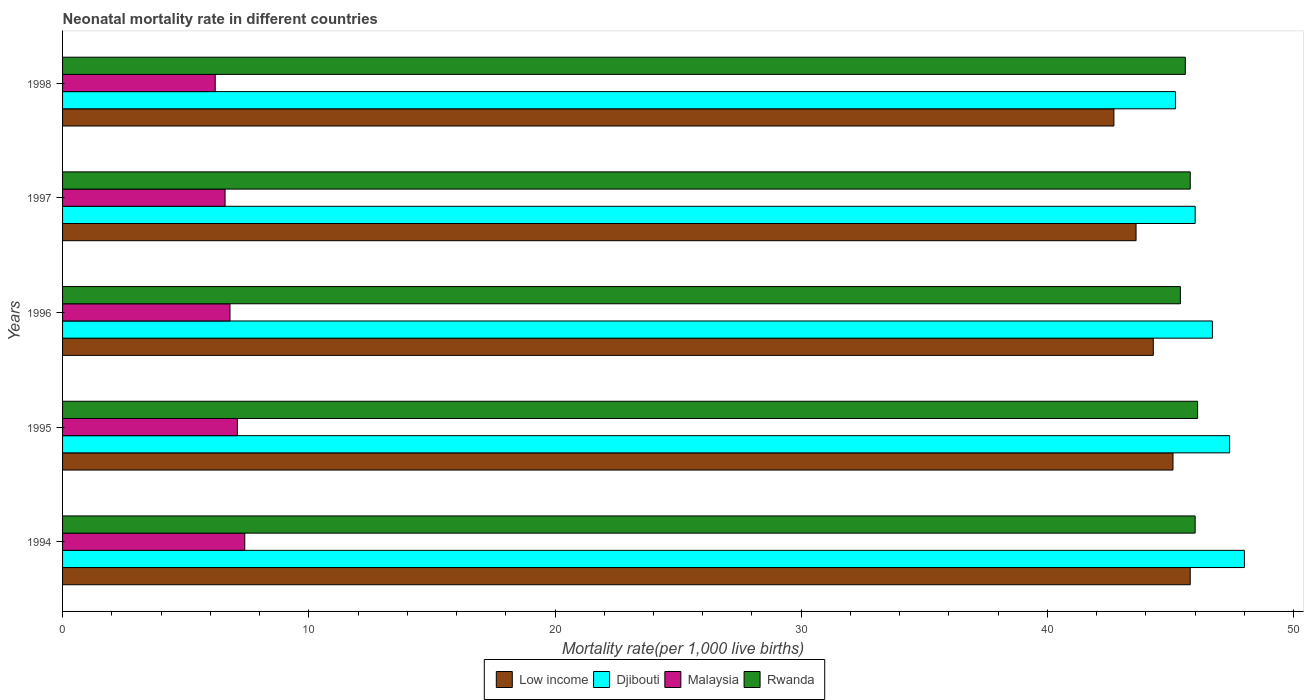Are the number of bars per tick equal to the number of legend labels?
Your answer should be very brief. Yes. Are the number of bars on each tick of the Y-axis equal?
Provide a succinct answer. Yes. How many bars are there on the 1st tick from the top?
Make the answer very short. 4. In how many cases, is the number of bars for a given year not equal to the number of legend labels?
Your answer should be compact. 0. What is the neonatal mortality rate in Djibouti in 1995?
Make the answer very short. 47.4. Across all years, what is the minimum neonatal mortality rate in Djibouti?
Ensure brevity in your answer.  45.2. In which year was the neonatal mortality rate in Low income maximum?
Offer a terse response. 1994. What is the total neonatal mortality rate in Djibouti in the graph?
Offer a terse response. 233.3. What is the difference between the neonatal mortality rate in Djibouti in 1994 and that in 1997?
Your answer should be very brief. 2. What is the difference between the neonatal mortality rate in Djibouti in 1996 and the neonatal mortality rate in Malaysia in 1998?
Your response must be concise. 40.5. What is the average neonatal mortality rate in Djibouti per year?
Give a very brief answer. 46.66. In the year 1997, what is the difference between the neonatal mortality rate in Low income and neonatal mortality rate in Rwanda?
Your answer should be very brief. -2.2. In how many years, is the neonatal mortality rate in Rwanda greater than 18 ?
Ensure brevity in your answer.  5. What is the ratio of the neonatal mortality rate in Low income in 1995 to that in 1996?
Give a very brief answer. 1.02. Is the neonatal mortality rate in Malaysia in 1995 less than that in 1997?
Keep it short and to the point. No. What is the difference between the highest and the second highest neonatal mortality rate in Djibouti?
Provide a short and direct response. 0.6. What is the difference between the highest and the lowest neonatal mortality rate in Malaysia?
Your answer should be compact. 1.2. What does the 2nd bar from the top in 1996 represents?
Provide a short and direct response. Malaysia. What does the 3rd bar from the bottom in 1998 represents?
Offer a very short reply. Malaysia. How many years are there in the graph?
Give a very brief answer. 5. What is the difference between two consecutive major ticks on the X-axis?
Your response must be concise. 10. Are the values on the major ticks of X-axis written in scientific E-notation?
Ensure brevity in your answer.  No. How many legend labels are there?
Offer a terse response. 4. How are the legend labels stacked?
Your answer should be very brief. Horizontal. What is the title of the graph?
Your answer should be very brief. Neonatal mortality rate in different countries. Does "Ireland" appear as one of the legend labels in the graph?
Provide a succinct answer. No. What is the label or title of the X-axis?
Offer a terse response. Mortality rate(per 1,0 live births). What is the label or title of the Y-axis?
Give a very brief answer. Years. What is the Mortality rate(per 1,000 live births) in Low income in 1994?
Ensure brevity in your answer.  45.8. What is the Mortality rate(per 1,000 live births) of Malaysia in 1994?
Your answer should be compact. 7.4. What is the Mortality rate(per 1,000 live births) of Low income in 1995?
Your answer should be compact. 45.1. What is the Mortality rate(per 1,000 live births) of Djibouti in 1995?
Provide a short and direct response. 47.4. What is the Mortality rate(per 1,000 live births) in Malaysia in 1995?
Provide a short and direct response. 7.1. What is the Mortality rate(per 1,000 live births) of Rwanda in 1995?
Ensure brevity in your answer.  46.1. What is the Mortality rate(per 1,000 live births) of Low income in 1996?
Keep it short and to the point. 44.3. What is the Mortality rate(per 1,000 live births) of Djibouti in 1996?
Your answer should be very brief. 46.7. What is the Mortality rate(per 1,000 live births) of Rwanda in 1996?
Your response must be concise. 45.4. What is the Mortality rate(per 1,000 live births) of Low income in 1997?
Offer a terse response. 43.6. What is the Mortality rate(per 1,000 live births) in Djibouti in 1997?
Your answer should be compact. 46. What is the Mortality rate(per 1,000 live births) in Malaysia in 1997?
Offer a very short reply. 6.6. What is the Mortality rate(per 1,000 live births) of Rwanda in 1997?
Offer a very short reply. 45.8. What is the Mortality rate(per 1,000 live births) in Low income in 1998?
Offer a terse response. 42.7. What is the Mortality rate(per 1,000 live births) of Djibouti in 1998?
Your response must be concise. 45.2. What is the Mortality rate(per 1,000 live births) in Rwanda in 1998?
Keep it short and to the point. 45.6. Across all years, what is the maximum Mortality rate(per 1,000 live births) of Low income?
Ensure brevity in your answer.  45.8. Across all years, what is the maximum Mortality rate(per 1,000 live births) of Djibouti?
Your answer should be very brief. 48. Across all years, what is the maximum Mortality rate(per 1,000 live births) of Rwanda?
Your response must be concise. 46.1. Across all years, what is the minimum Mortality rate(per 1,000 live births) in Low income?
Your answer should be very brief. 42.7. Across all years, what is the minimum Mortality rate(per 1,000 live births) of Djibouti?
Give a very brief answer. 45.2. Across all years, what is the minimum Mortality rate(per 1,000 live births) in Malaysia?
Your answer should be very brief. 6.2. Across all years, what is the minimum Mortality rate(per 1,000 live births) in Rwanda?
Make the answer very short. 45.4. What is the total Mortality rate(per 1,000 live births) of Low income in the graph?
Offer a terse response. 221.5. What is the total Mortality rate(per 1,000 live births) in Djibouti in the graph?
Provide a short and direct response. 233.3. What is the total Mortality rate(per 1,000 live births) of Malaysia in the graph?
Provide a succinct answer. 34.1. What is the total Mortality rate(per 1,000 live births) in Rwanda in the graph?
Your answer should be compact. 228.9. What is the difference between the Mortality rate(per 1,000 live births) of Djibouti in 1994 and that in 1995?
Your response must be concise. 0.6. What is the difference between the Mortality rate(per 1,000 live births) in Malaysia in 1994 and that in 1995?
Your response must be concise. 0.3. What is the difference between the Mortality rate(per 1,000 live births) in Low income in 1994 and that in 1996?
Give a very brief answer. 1.5. What is the difference between the Mortality rate(per 1,000 live births) of Low income in 1994 and that in 1997?
Your answer should be very brief. 2.2. What is the difference between the Mortality rate(per 1,000 live births) of Djibouti in 1994 and that in 1997?
Offer a very short reply. 2. What is the difference between the Mortality rate(per 1,000 live births) of Malaysia in 1994 and that in 1997?
Your answer should be compact. 0.8. What is the difference between the Mortality rate(per 1,000 live births) of Rwanda in 1994 and that in 1997?
Offer a very short reply. 0.2. What is the difference between the Mortality rate(per 1,000 live births) of Malaysia in 1994 and that in 1998?
Offer a terse response. 1.2. What is the difference between the Mortality rate(per 1,000 live births) in Djibouti in 1995 and that in 1996?
Your response must be concise. 0.7. What is the difference between the Mortality rate(per 1,000 live births) of Rwanda in 1995 and that in 1996?
Offer a terse response. 0.7. What is the difference between the Mortality rate(per 1,000 live births) in Djibouti in 1995 and that in 1998?
Offer a terse response. 2.2. What is the difference between the Mortality rate(per 1,000 live births) in Rwanda in 1995 and that in 1998?
Make the answer very short. 0.5. What is the difference between the Mortality rate(per 1,000 live births) of Low income in 1996 and that in 1998?
Offer a terse response. 1.6. What is the difference between the Mortality rate(per 1,000 live births) of Djibouti in 1996 and that in 1998?
Provide a short and direct response. 1.5. What is the difference between the Mortality rate(per 1,000 live births) in Rwanda in 1996 and that in 1998?
Provide a short and direct response. -0.2. What is the difference between the Mortality rate(per 1,000 live births) in Malaysia in 1997 and that in 1998?
Offer a very short reply. 0.4. What is the difference between the Mortality rate(per 1,000 live births) in Low income in 1994 and the Mortality rate(per 1,000 live births) in Malaysia in 1995?
Offer a very short reply. 38.7. What is the difference between the Mortality rate(per 1,000 live births) of Djibouti in 1994 and the Mortality rate(per 1,000 live births) of Malaysia in 1995?
Offer a very short reply. 40.9. What is the difference between the Mortality rate(per 1,000 live births) of Djibouti in 1994 and the Mortality rate(per 1,000 live births) of Rwanda in 1995?
Your answer should be compact. 1.9. What is the difference between the Mortality rate(per 1,000 live births) in Malaysia in 1994 and the Mortality rate(per 1,000 live births) in Rwanda in 1995?
Offer a terse response. -38.7. What is the difference between the Mortality rate(per 1,000 live births) of Low income in 1994 and the Mortality rate(per 1,000 live births) of Rwanda in 1996?
Offer a very short reply. 0.4. What is the difference between the Mortality rate(per 1,000 live births) in Djibouti in 1994 and the Mortality rate(per 1,000 live births) in Malaysia in 1996?
Give a very brief answer. 41.2. What is the difference between the Mortality rate(per 1,000 live births) of Malaysia in 1994 and the Mortality rate(per 1,000 live births) of Rwanda in 1996?
Your answer should be compact. -38. What is the difference between the Mortality rate(per 1,000 live births) of Low income in 1994 and the Mortality rate(per 1,000 live births) of Malaysia in 1997?
Make the answer very short. 39.2. What is the difference between the Mortality rate(per 1,000 live births) in Djibouti in 1994 and the Mortality rate(per 1,000 live births) in Malaysia in 1997?
Offer a very short reply. 41.4. What is the difference between the Mortality rate(per 1,000 live births) of Malaysia in 1994 and the Mortality rate(per 1,000 live births) of Rwanda in 1997?
Your answer should be compact. -38.4. What is the difference between the Mortality rate(per 1,000 live births) in Low income in 1994 and the Mortality rate(per 1,000 live births) in Malaysia in 1998?
Give a very brief answer. 39.6. What is the difference between the Mortality rate(per 1,000 live births) of Low income in 1994 and the Mortality rate(per 1,000 live births) of Rwanda in 1998?
Your answer should be compact. 0.2. What is the difference between the Mortality rate(per 1,000 live births) of Djibouti in 1994 and the Mortality rate(per 1,000 live births) of Malaysia in 1998?
Provide a succinct answer. 41.8. What is the difference between the Mortality rate(per 1,000 live births) of Malaysia in 1994 and the Mortality rate(per 1,000 live births) of Rwanda in 1998?
Offer a terse response. -38.2. What is the difference between the Mortality rate(per 1,000 live births) of Low income in 1995 and the Mortality rate(per 1,000 live births) of Djibouti in 1996?
Offer a terse response. -1.6. What is the difference between the Mortality rate(per 1,000 live births) of Low income in 1995 and the Mortality rate(per 1,000 live births) of Malaysia in 1996?
Keep it short and to the point. 38.3. What is the difference between the Mortality rate(per 1,000 live births) of Djibouti in 1995 and the Mortality rate(per 1,000 live births) of Malaysia in 1996?
Provide a short and direct response. 40.6. What is the difference between the Mortality rate(per 1,000 live births) in Djibouti in 1995 and the Mortality rate(per 1,000 live births) in Rwanda in 1996?
Your answer should be very brief. 2. What is the difference between the Mortality rate(per 1,000 live births) in Malaysia in 1995 and the Mortality rate(per 1,000 live births) in Rwanda in 1996?
Keep it short and to the point. -38.3. What is the difference between the Mortality rate(per 1,000 live births) of Low income in 1995 and the Mortality rate(per 1,000 live births) of Djibouti in 1997?
Provide a succinct answer. -0.9. What is the difference between the Mortality rate(per 1,000 live births) in Low income in 1995 and the Mortality rate(per 1,000 live births) in Malaysia in 1997?
Provide a succinct answer. 38.5. What is the difference between the Mortality rate(per 1,000 live births) of Low income in 1995 and the Mortality rate(per 1,000 live births) of Rwanda in 1997?
Your answer should be very brief. -0.7. What is the difference between the Mortality rate(per 1,000 live births) in Djibouti in 1995 and the Mortality rate(per 1,000 live births) in Malaysia in 1997?
Make the answer very short. 40.8. What is the difference between the Mortality rate(per 1,000 live births) in Malaysia in 1995 and the Mortality rate(per 1,000 live births) in Rwanda in 1997?
Give a very brief answer. -38.7. What is the difference between the Mortality rate(per 1,000 live births) in Low income in 1995 and the Mortality rate(per 1,000 live births) in Malaysia in 1998?
Make the answer very short. 38.9. What is the difference between the Mortality rate(per 1,000 live births) in Low income in 1995 and the Mortality rate(per 1,000 live births) in Rwanda in 1998?
Your answer should be compact. -0.5. What is the difference between the Mortality rate(per 1,000 live births) of Djibouti in 1995 and the Mortality rate(per 1,000 live births) of Malaysia in 1998?
Your answer should be very brief. 41.2. What is the difference between the Mortality rate(per 1,000 live births) in Malaysia in 1995 and the Mortality rate(per 1,000 live births) in Rwanda in 1998?
Your answer should be very brief. -38.5. What is the difference between the Mortality rate(per 1,000 live births) of Low income in 1996 and the Mortality rate(per 1,000 live births) of Djibouti in 1997?
Ensure brevity in your answer.  -1.7. What is the difference between the Mortality rate(per 1,000 live births) in Low income in 1996 and the Mortality rate(per 1,000 live births) in Malaysia in 1997?
Provide a succinct answer. 37.7. What is the difference between the Mortality rate(per 1,000 live births) in Djibouti in 1996 and the Mortality rate(per 1,000 live births) in Malaysia in 1997?
Your answer should be very brief. 40.1. What is the difference between the Mortality rate(per 1,000 live births) in Djibouti in 1996 and the Mortality rate(per 1,000 live births) in Rwanda in 1997?
Offer a very short reply. 0.9. What is the difference between the Mortality rate(per 1,000 live births) of Malaysia in 1996 and the Mortality rate(per 1,000 live births) of Rwanda in 1997?
Your answer should be very brief. -39. What is the difference between the Mortality rate(per 1,000 live births) of Low income in 1996 and the Mortality rate(per 1,000 live births) of Malaysia in 1998?
Offer a very short reply. 38.1. What is the difference between the Mortality rate(per 1,000 live births) of Djibouti in 1996 and the Mortality rate(per 1,000 live births) of Malaysia in 1998?
Offer a very short reply. 40.5. What is the difference between the Mortality rate(per 1,000 live births) in Malaysia in 1996 and the Mortality rate(per 1,000 live births) in Rwanda in 1998?
Your answer should be compact. -38.8. What is the difference between the Mortality rate(per 1,000 live births) of Low income in 1997 and the Mortality rate(per 1,000 live births) of Malaysia in 1998?
Offer a very short reply. 37.4. What is the difference between the Mortality rate(per 1,000 live births) of Low income in 1997 and the Mortality rate(per 1,000 live births) of Rwanda in 1998?
Offer a terse response. -2. What is the difference between the Mortality rate(per 1,000 live births) of Djibouti in 1997 and the Mortality rate(per 1,000 live births) of Malaysia in 1998?
Provide a short and direct response. 39.8. What is the difference between the Mortality rate(per 1,000 live births) of Djibouti in 1997 and the Mortality rate(per 1,000 live births) of Rwanda in 1998?
Ensure brevity in your answer.  0.4. What is the difference between the Mortality rate(per 1,000 live births) in Malaysia in 1997 and the Mortality rate(per 1,000 live births) in Rwanda in 1998?
Your answer should be very brief. -39. What is the average Mortality rate(per 1,000 live births) in Low income per year?
Offer a terse response. 44.3. What is the average Mortality rate(per 1,000 live births) in Djibouti per year?
Your response must be concise. 46.66. What is the average Mortality rate(per 1,000 live births) in Malaysia per year?
Provide a succinct answer. 6.82. What is the average Mortality rate(per 1,000 live births) of Rwanda per year?
Offer a very short reply. 45.78. In the year 1994, what is the difference between the Mortality rate(per 1,000 live births) in Low income and Mortality rate(per 1,000 live births) in Malaysia?
Your answer should be compact. 38.4. In the year 1994, what is the difference between the Mortality rate(per 1,000 live births) in Djibouti and Mortality rate(per 1,000 live births) in Malaysia?
Provide a succinct answer. 40.6. In the year 1994, what is the difference between the Mortality rate(per 1,000 live births) in Malaysia and Mortality rate(per 1,000 live births) in Rwanda?
Offer a terse response. -38.6. In the year 1995, what is the difference between the Mortality rate(per 1,000 live births) in Low income and Mortality rate(per 1,000 live births) in Djibouti?
Your response must be concise. -2.3. In the year 1995, what is the difference between the Mortality rate(per 1,000 live births) of Low income and Mortality rate(per 1,000 live births) of Rwanda?
Provide a short and direct response. -1. In the year 1995, what is the difference between the Mortality rate(per 1,000 live births) of Djibouti and Mortality rate(per 1,000 live births) of Malaysia?
Keep it short and to the point. 40.3. In the year 1995, what is the difference between the Mortality rate(per 1,000 live births) of Malaysia and Mortality rate(per 1,000 live births) of Rwanda?
Keep it short and to the point. -39. In the year 1996, what is the difference between the Mortality rate(per 1,000 live births) of Low income and Mortality rate(per 1,000 live births) of Djibouti?
Your response must be concise. -2.4. In the year 1996, what is the difference between the Mortality rate(per 1,000 live births) of Low income and Mortality rate(per 1,000 live births) of Malaysia?
Provide a succinct answer. 37.5. In the year 1996, what is the difference between the Mortality rate(per 1,000 live births) in Low income and Mortality rate(per 1,000 live births) in Rwanda?
Offer a very short reply. -1.1. In the year 1996, what is the difference between the Mortality rate(per 1,000 live births) in Djibouti and Mortality rate(per 1,000 live births) in Malaysia?
Ensure brevity in your answer.  39.9. In the year 1996, what is the difference between the Mortality rate(per 1,000 live births) of Djibouti and Mortality rate(per 1,000 live births) of Rwanda?
Make the answer very short. 1.3. In the year 1996, what is the difference between the Mortality rate(per 1,000 live births) in Malaysia and Mortality rate(per 1,000 live births) in Rwanda?
Provide a short and direct response. -38.6. In the year 1997, what is the difference between the Mortality rate(per 1,000 live births) in Low income and Mortality rate(per 1,000 live births) in Djibouti?
Provide a succinct answer. -2.4. In the year 1997, what is the difference between the Mortality rate(per 1,000 live births) of Low income and Mortality rate(per 1,000 live births) of Malaysia?
Your response must be concise. 37. In the year 1997, what is the difference between the Mortality rate(per 1,000 live births) in Low income and Mortality rate(per 1,000 live births) in Rwanda?
Provide a succinct answer. -2.2. In the year 1997, what is the difference between the Mortality rate(per 1,000 live births) in Djibouti and Mortality rate(per 1,000 live births) in Malaysia?
Provide a succinct answer. 39.4. In the year 1997, what is the difference between the Mortality rate(per 1,000 live births) in Malaysia and Mortality rate(per 1,000 live births) in Rwanda?
Provide a succinct answer. -39.2. In the year 1998, what is the difference between the Mortality rate(per 1,000 live births) in Low income and Mortality rate(per 1,000 live births) in Djibouti?
Offer a terse response. -2.5. In the year 1998, what is the difference between the Mortality rate(per 1,000 live births) in Low income and Mortality rate(per 1,000 live births) in Malaysia?
Your answer should be very brief. 36.5. In the year 1998, what is the difference between the Mortality rate(per 1,000 live births) of Low income and Mortality rate(per 1,000 live births) of Rwanda?
Offer a very short reply. -2.9. In the year 1998, what is the difference between the Mortality rate(per 1,000 live births) of Djibouti and Mortality rate(per 1,000 live births) of Malaysia?
Ensure brevity in your answer.  39. In the year 1998, what is the difference between the Mortality rate(per 1,000 live births) of Djibouti and Mortality rate(per 1,000 live births) of Rwanda?
Keep it short and to the point. -0.4. In the year 1998, what is the difference between the Mortality rate(per 1,000 live births) in Malaysia and Mortality rate(per 1,000 live births) in Rwanda?
Keep it short and to the point. -39.4. What is the ratio of the Mortality rate(per 1,000 live births) in Low income in 1994 to that in 1995?
Offer a very short reply. 1.02. What is the ratio of the Mortality rate(per 1,000 live births) in Djibouti in 1994 to that in 1995?
Make the answer very short. 1.01. What is the ratio of the Mortality rate(per 1,000 live births) in Malaysia in 1994 to that in 1995?
Keep it short and to the point. 1.04. What is the ratio of the Mortality rate(per 1,000 live births) in Low income in 1994 to that in 1996?
Ensure brevity in your answer.  1.03. What is the ratio of the Mortality rate(per 1,000 live births) in Djibouti in 1994 to that in 1996?
Your answer should be compact. 1.03. What is the ratio of the Mortality rate(per 1,000 live births) in Malaysia in 1994 to that in 1996?
Your response must be concise. 1.09. What is the ratio of the Mortality rate(per 1,000 live births) in Rwanda in 1994 to that in 1996?
Provide a succinct answer. 1.01. What is the ratio of the Mortality rate(per 1,000 live births) of Low income in 1994 to that in 1997?
Give a very brief answer. 1.05. What is the ratio of the Mortality rate(per 1,000 live births) of Djibouti in 1994 to that in 1997?
Provide a short and direct response. 1.04. What is the ratio of the Mortality rate(per 1,000 live births) of Malaysia in 1994 to that in 1997?
Your response must be concise. 1.12. What is the ratio of the Mortality rate(per 1,000 live births) of Rwanda in 1994 to that in 1997?
Keep it short and to the point. 1. What is the ratio of the Mortality rate(per 1,000 live births) in Low income in 1994 to that in 1998?
Your answer should be very brief. 1.07. What is the ratio of the Mortality rate(per 1,000 live births) of Djibouti in 1994 to that in 1998?
Ensure brevity in your answer.  1.06. What is the ratio of the Mortality rate(per 1,000 live births) in Malaysia in 1994 to that in 1998?
Ensure brevity in your answer.  1.19. What is the ratio of the Mortality rate(per 1,000 live births) of Rwanda in 1994 to that in 1998?
Ensure brevity in your answer.  1.01. What is the ratio of the Mortality rate(per 1,000 live births) of Low income in 1995 to that in 1996?
Your response must be concise. 1.02. What is the ratio of the Mortality rate(per 1,000 live births) in Malaysia in 1995 to that in 1996?
Ensure brevity in your answer.  1.04. What is the ratio of the Mortality rate(per 1,000 live births) of Rwanda in 1995 to that in 1996?
Your answer should be very brief. 1.02. What is the ratio of the Mortality rate(per 1,000 live births) of Low income in 1995 to that in 1997?
Ensure brevity in your answer.  1.03. What is the ratio of the Mortality rate(per 1,000 live births) in Djibouti in 1995 to that in 1997?
Offer a very short reply. 1.03. What is the ratio of the Mortality rate(per 1,000 live births) of Malaysia in 1995 to that in 1997?
Your answer should be very brief. 1.08. What is the ratio of the Mortality rate(per 1,000 live births) in Rwanda in 1995 to that in 1997?
Your response must be concise. 1.01. What is the ratio of the Mortality rate(per 1,000 live births) in Low income in 1995 to that in 1998?
Your answer should be compact. 1.06. What is the ratio of the Mortality rate(per 1,000 live births) of Djibouti in 1995 to that in 1998?
Ensure brevity in your answer.  1.05. What is the ratio of the Mortality rate(per 1,000 live births) in Malaysia in 1995 to that in 1998?
Provide a succinct answer. 1.15. What is the ratio of the Mortality rate(per 1,000 live births) in Low income in 1996 to that in 1997?
Offer a very short reply. 1.02. What is the ratio of the Mortality rate(per 1,000 live births) of Djibouti in 1996 to that in 1997?
Offer a very short reply. 1.02. What is the ratio of the Mortality rate(per 1,000 live births) in Malaysia in 1996 to that in 1997?
Provide a short and direct response. 1.03. What is the ratio of the Mortality rate(per 1,000 live births) in Low income in 1996 to that in 1998?
Offer a very short reply. 1.04. What is the ratio of the Mortality rate(per 1,000 live births) of Djibouti in 1996 to that in 1998?
Make the answer very short. 1.03. What is the ratio of the Mortality rate(per 1,000 live births) of Malaysia in 1996 to that in 1998?
Provide a succinct answer. 1.1. What is the ratio of the Mortality rate(per 1,000 live births) of Low income in 1997 to that in 1998?
Offer a very short reply. 1.02. What is the ratio of the Mortality rate(per 1,000 live births) in Djibouti in 1997 to that in 1998?
Give a very brief answer. 1.02. What is the ratio of the Mortality rate(per 1,000 live births) in Malaysia in 1997 to that in 1998?
Keep it short and to the point. 1.06. What is the difference between the highest and the second highest Mortality rate(per 1,000 live births) in Low income?
Your answer should be very brief. 0.7. What is the difference between the highest and the second highest Mortality rate(per 1,000 live births) of Djibouti?
Your response must be concise. 0.6. What is the difference between the highest and the second highest Mortality rate(per 1,000 live births) in Rwanda?
Make the answer very short. 0.1. What is the difference between the highest and the lowest Mortality rate(per 1,000 live births) of Djibouti?
Give a very brief answer. 2.8. What is the difference between the highest and the lowest Mortality rate(per 1,000 live births) in Rwanda?
Ensure brevity in your answer.  0.7. 